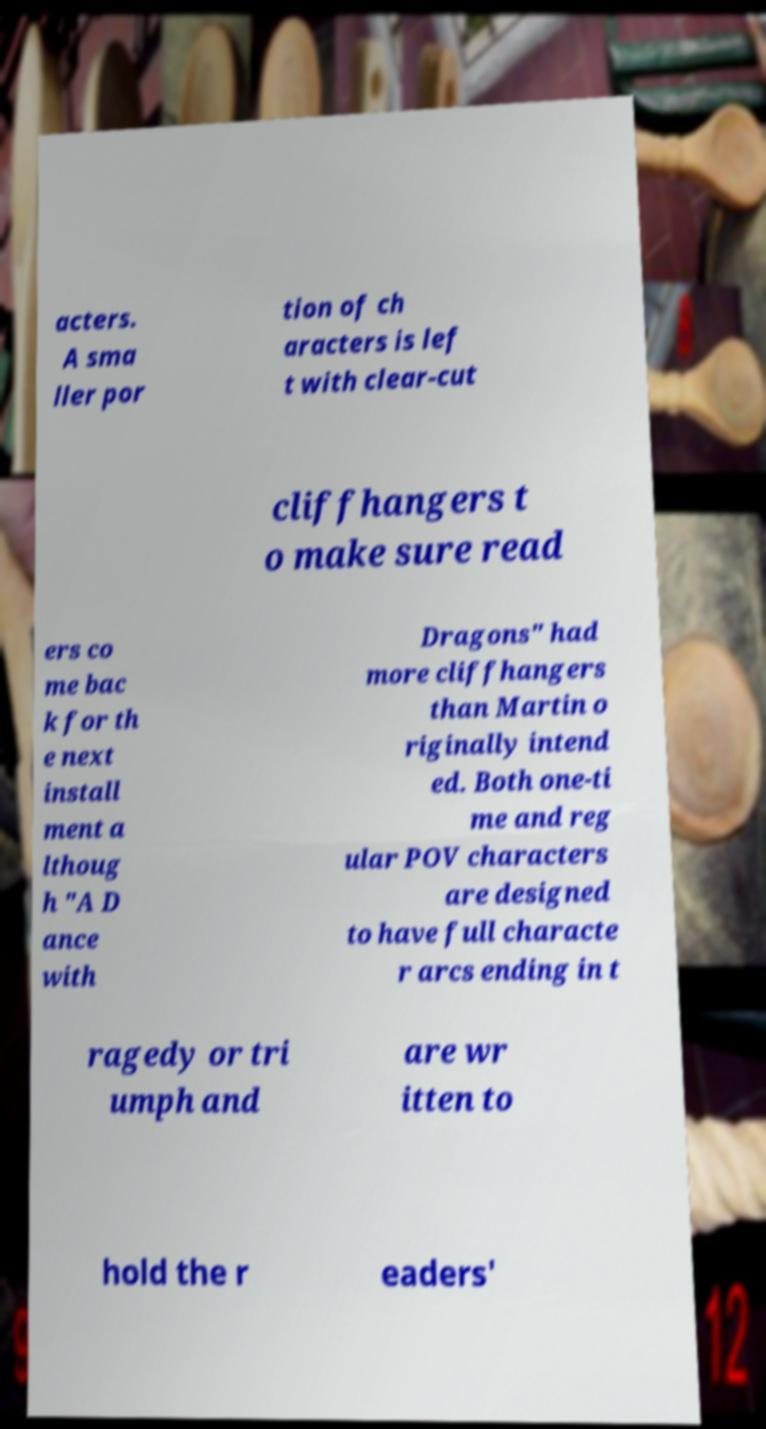For documentation purposes, I need the text within this image transcribed. Could you provide that? acters. A sma ller por tion of ch aracters is lef t with clear-cut cliffhangers t o make sure read ers co me bac k for th e next install ment a lthoug h "A D ance with Dragons" had more cliffhangers than Martin o riginally intend ed. Both one-ti me and reg ular POV characters are designed to have full characte r arcs ending in t ragedy or tri umph and are wr itten to hold the r eaders' 